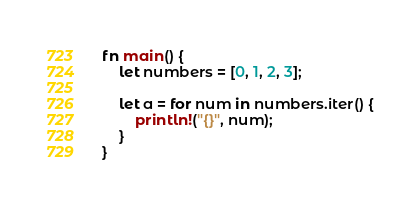<code> <loc_0><loc_0><loc_500><loc_500><_Rust_>fn main() {
    let numbers = [0, 1, 2, 3];

    let a = for num in numbers.iter() {
        println!("{}", num);
    }
}
</code> 